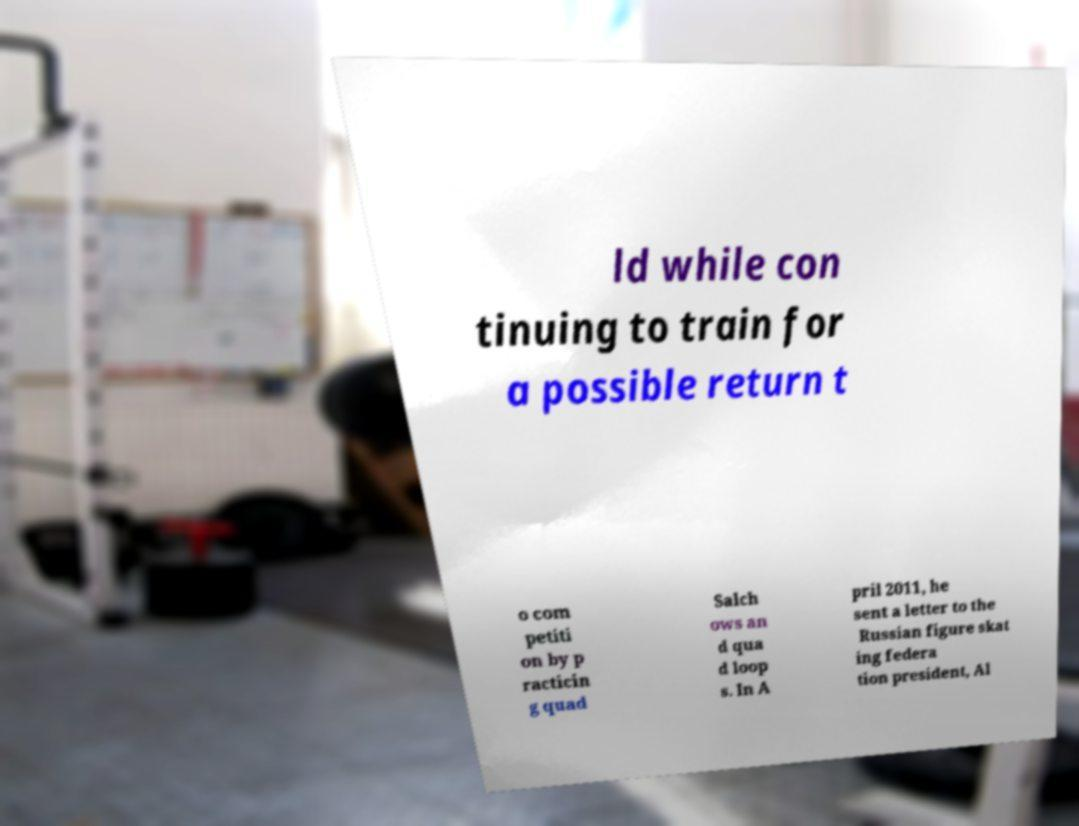Can you read and provide the text displayed in the image?This photo seems to have some interesting text. Can you extract and type it out for me? ld while con tinuing to train for a possible return t o com petiti on by p racticin g quad Salch ows an d qua d loop s. In A pril 2011, he sent a letter to the Russian figure skat ing federa tion president, Al 